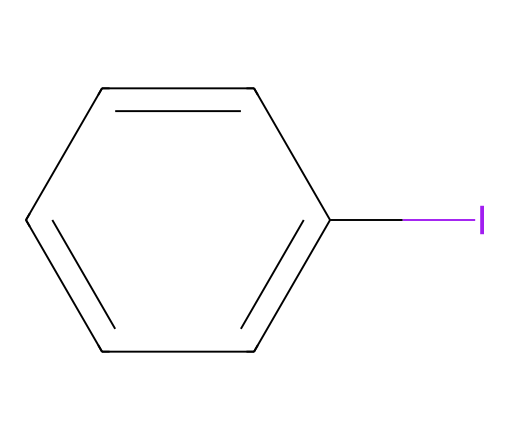What is the molecular structure represented here? The SMILES notation indicates a six-membered aromatic ring with an iodine substituent. The presence of "C" signifies carbon atoms and the arrangement shows a benzene-like structure with the iodine atom attached.
Answer: iodine-substituted aromatic compound How many carbon atoms are in this molecule? Counting the "C" symbols in the SMILES notation reveals that there are six carbon atoms in the molecular structure.
Answer: six What is the degree of unsaturation in this molecule? The presence of a benzene ring indicates that the molecule has a degree of unsaturation due to the alternating double bonds, which results in one degree of unsaturation for the cyclic structure present.
Answer: one What type of halogen is present in this molecule? The SMILES contains the symbol "I", which represents iodine, confirming that this molecule contains the halogen iodine.
Answer: iodine What is the significance of iodine in biocides? Iodine is often used in biocides because of its ability to disrupt microbial growth and ensure the preservation of wood materials by preventing decay and fungal growth.
Answer: antimicrobial Does this compound have any double bonds in its structure? The molecular structure derived from the SMILES shows alternating single and double bonds indicated by the cyclic arrangement of carbon atoms, confirming the presence of double bonds.
Answer: yes What kind of reaction would you expect this compound to undergo for wood preservation? Given that this is an iodine-based compound, it can undergo reactions such as substitution reactions where the iodine can react with wood components, leading to preservation and anti-fungal properties.
Answer: substitution reaction 